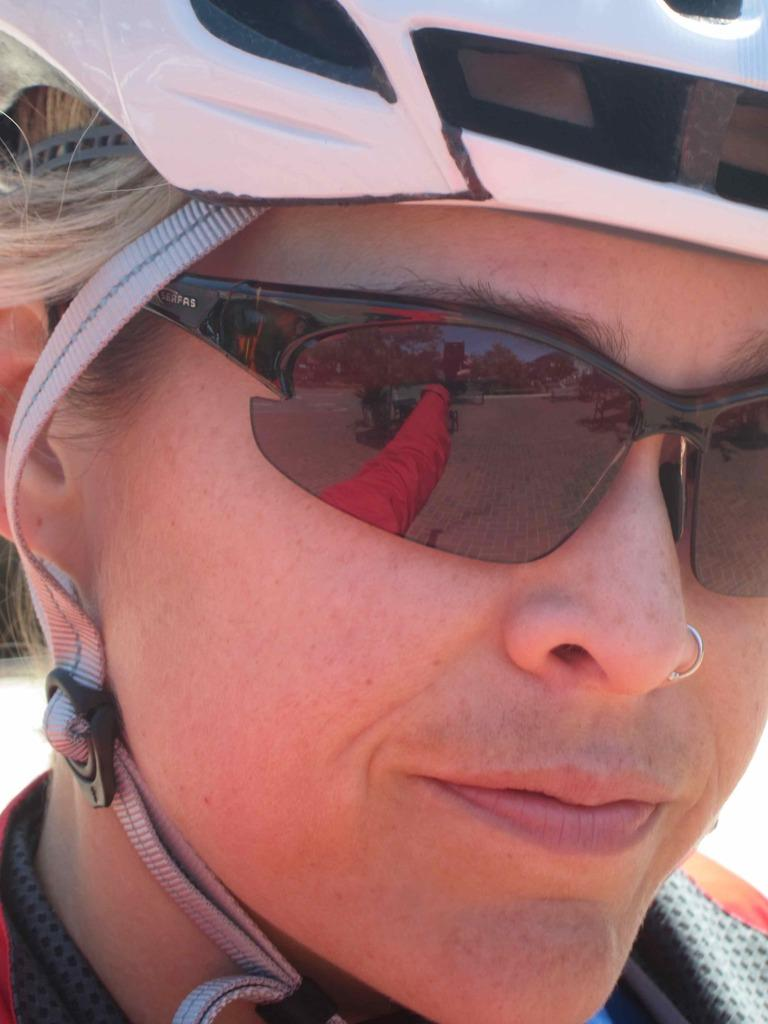What can be seen in the image? There is a person's face in the image. What protective gear is the person wearing? The person is wearing a helmet and goggles. What type of accessory is the person wearing on their face? The person is wearing a nose ring. What can be seen in the reflections of the image? There are reflections of trees, the sky, and a person's hand on the lens. What chess piece is the person holding in the image? There is no chess piece visible in the image. What type of rat can be seen in the image? There is no rat present in the image. 